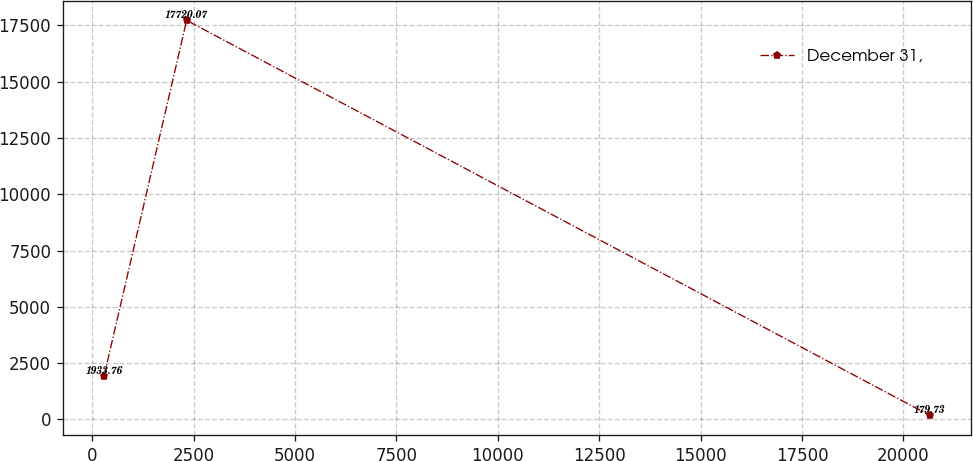Convert chart to OTSL. <chart><loc_0><loc_0><loc_500><loc_500><line_chart><ecel><fcel>December 31,<nl><fcel>291.92<fcel>1933.76<nl><fcel>2327.49<fcel>17720.1<nl><fcel>20647.6<fcel>179.73<nl></chart> 